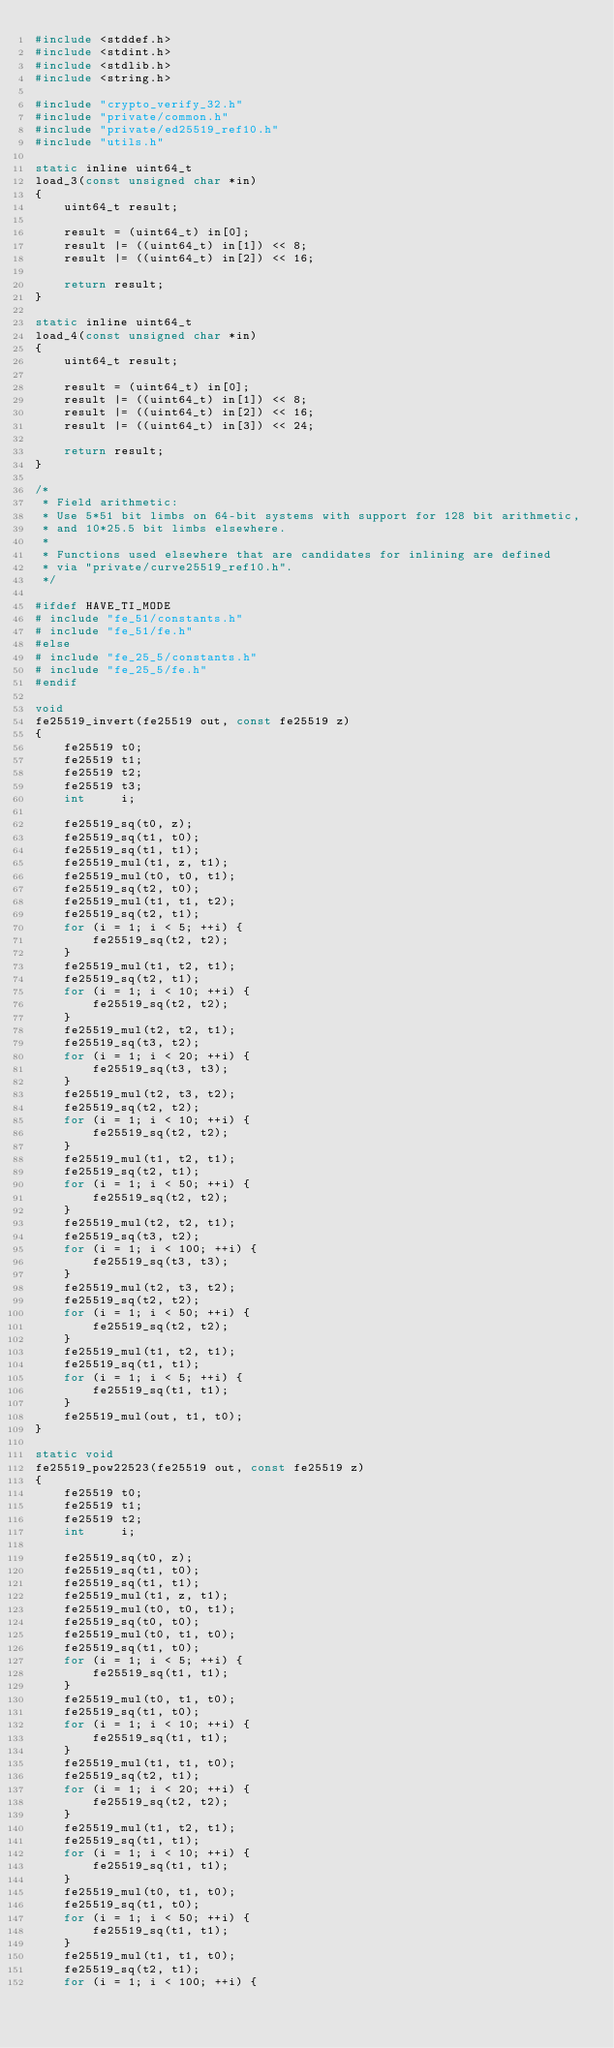Convert code to text. <code><loc_0><loc_0><loc_500><loc_500><_C_>#include <stddef.h>
#include <stdint.h>
#include <stdlib.h>
#include <string.h>

#include "crypto_verify_32.h"
#include "private/common.h"
#include "private/ed25519_ref10.h"
#include "utils.h"

static inline uint64_t
load_3(const unsigned char *in)
{
    uint64_t result;

    result = (uint64_t) in[0];
    result |= ((uint64_t) in[1]) << 8;
    result |= ((uint64_t) in[2]) << 16;

    return result;
}

static inline uint64_t
load_4(const unsigned char *in)
{
    uint64_t result;

    result = (uint64_t) in[0];
    result |= ((uint64_t) in[1]) << 8;
    result |= ((uint64_t) in[2]) << 16;
    result |= ((uint64_t) in[3]) << 24;

    return result;
}

/*
 * Field arithmetic:
 * Use 5*51 bit limbs on 64-bit systems with support for 128 bit arithmetic,
 * and 10*25.5 bit limbs elsewhere.
 *
 * Functions used elsewhere that are candidates for inlining are defined
 * via "private/curve25519_ref10.h".
 */

#ifdef HAVE_TI_MODE
# include "fe_51/constants.h"
# include "fe_51/fe.h"
#else
# include "fe_25_5/constants.h"
# include "fe_25_5/fe.h"
#endif

void
fe25519_invert(fe25519 out, const fe25519 z)
{
    fe25519 t0;
    fe25519 t1;
    fe25519 t2;
    fe25519 t3;
    int     i;

    fe25519_sq(t0, z);
    fe25519_sq(t1, t0);
    fe25519_sq(t1, t1);
    fe25519_mul(t1, z, t1);
    fe25519_mul(t0, t0, t1);
    fe25519_sq(t2, t0);
    fe25519_mul(t1, t1, t2);
    fe25519_sq(t2, t1);
    for (i = 1; i < 5; ++i) {
        fe25519_sq(t2, t2);
    }
    fe25519_mul(t1, t2, t1);
    fe25519_sq(t2, t1);
    for (i = 1; i < 10; ++i) {
        fe25519_sq(t2, t2);
    }
    fe25519_mul(t2, t2, t1);
    fe25519_sq(t3, t2);
    for (i = 1; i < 20; ++i) {
        fe25519_sq(t3, t3);
    }
    fe25519_mul(t2, t3, t2);
    fe25519_sq(t2, t2);
    for (i = 1; i < 10; ++i) {
        fe25519_sq(t2, t2);
    }
    fe25519_mul(t1, t2, t1);
    fe25519_sq(t2, t1);
    for (i = 1; i < 50; ++i) {
        fe25519_sq(t2, t2);
    }
    fe25519_mul(t2, t2, t1);
    fe25519_sq(t3, t2);
    for (i = 1; i < 100; ++i) {
        fe25519_sq(t3, t3);
    }
    fe25519_mul(t2, t3, t2);
    fe25519_sq(t2, t2);
    for (i = 1; i < 50; ++i) {
        fe25519_sq(t2, t2);
    }
    fe25519_mul(t1, t2, t1);
    fe25519_sq(t1, t1);
    for (i = 1; i < 5; ++i) {
        fe25519_sq(t1, t1);
    }
    fe25519_mul(out, t1, t0);
}

static void
fe25519_pow22523(fe25519 out, const fe25519 z)
{
    fe25519 t0;
    fe25519 t1;
    fe25519 t2;
    int     i;

    fe25519_sq(t0, z);
    fe25519_sq(t1, t0);
    fe25519_sq(t1, t1);
    fe25519_mul(t1, z, t1);
    fe25519_mul(t0, t0, t1);
    fe25519_sq(t0, t0);
    fe25519_mul(t0, t1, t0);
    fe25519_sq(t1, t0);
    for (i = 1; i < 5; ++i) {
        fe25519_sq(t1, t1);
    }
    fe25519_mul(t0, t1, t0);
    fe25519_sq(t1, t0);
    for (i = 1; i < 10; ++i) {
        fe25519_sq(t1, t1);
    }
    fe25519_mul(t1, t1, t0);
    fe25519_sq(t2, t1);
    for (i = 1; i < 20; ++i) {
        fe25519_sq(t2, t2);
    }
    fe25519_mul(t1, t2, t1);
    fe25519_sq(t1, t1);
    for (i = 1; i < 10; ++i) {
        fe25519_sq(t1, t1);
    }
    fe25519_mul(t0, t1, t0);
    fe25519_sq(t1, t0);
    for (i = 1; i < 50; ++i) {
        fe25519_sq(t1, t1);
    }
    fe25519_mul(t1, t1, t0);
    fe25519_sq(t2, t1);
    for (i = 1; i < 100; ++i) {</code> 